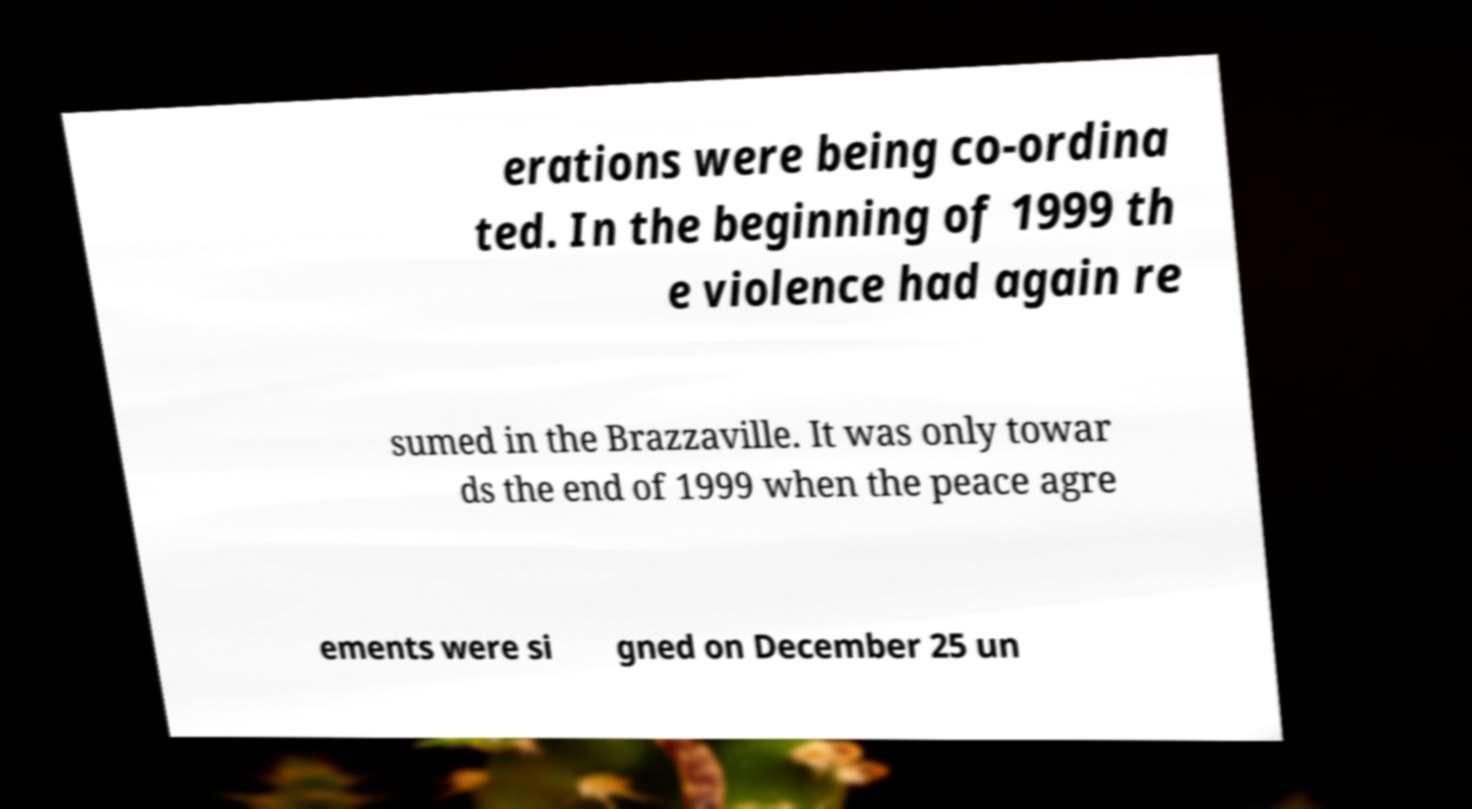Could you extract and type out the text from this image? erations were being co-ordina ted. In the beginning of 1999 th e violence had again re sumed in the Brazzaville. It was only towar ds the end of 1999 when the peace agre ements were si gned on December 25 un 